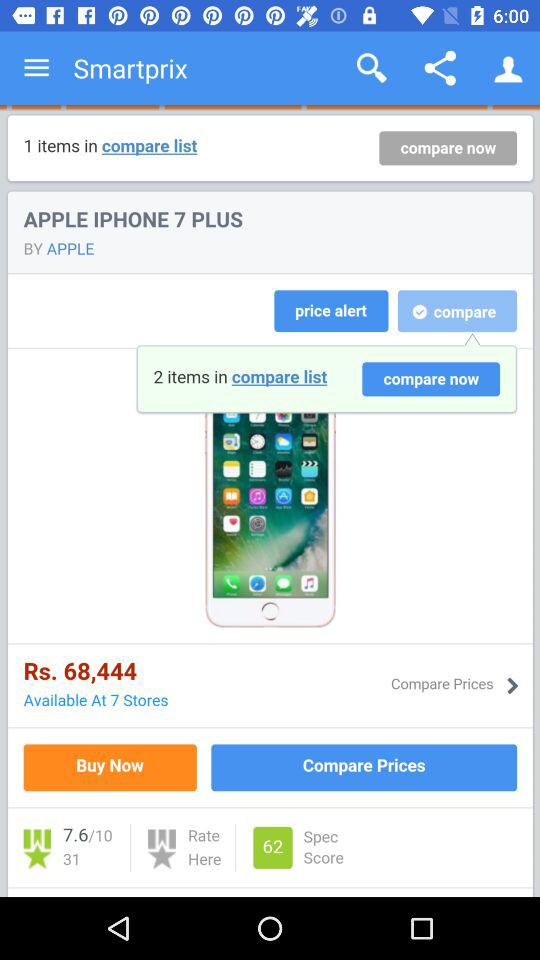What is the ranking for the Apple iPhone 7 Plus?
When the provided information is insufficient, respond with <no answer>. <no answer> 